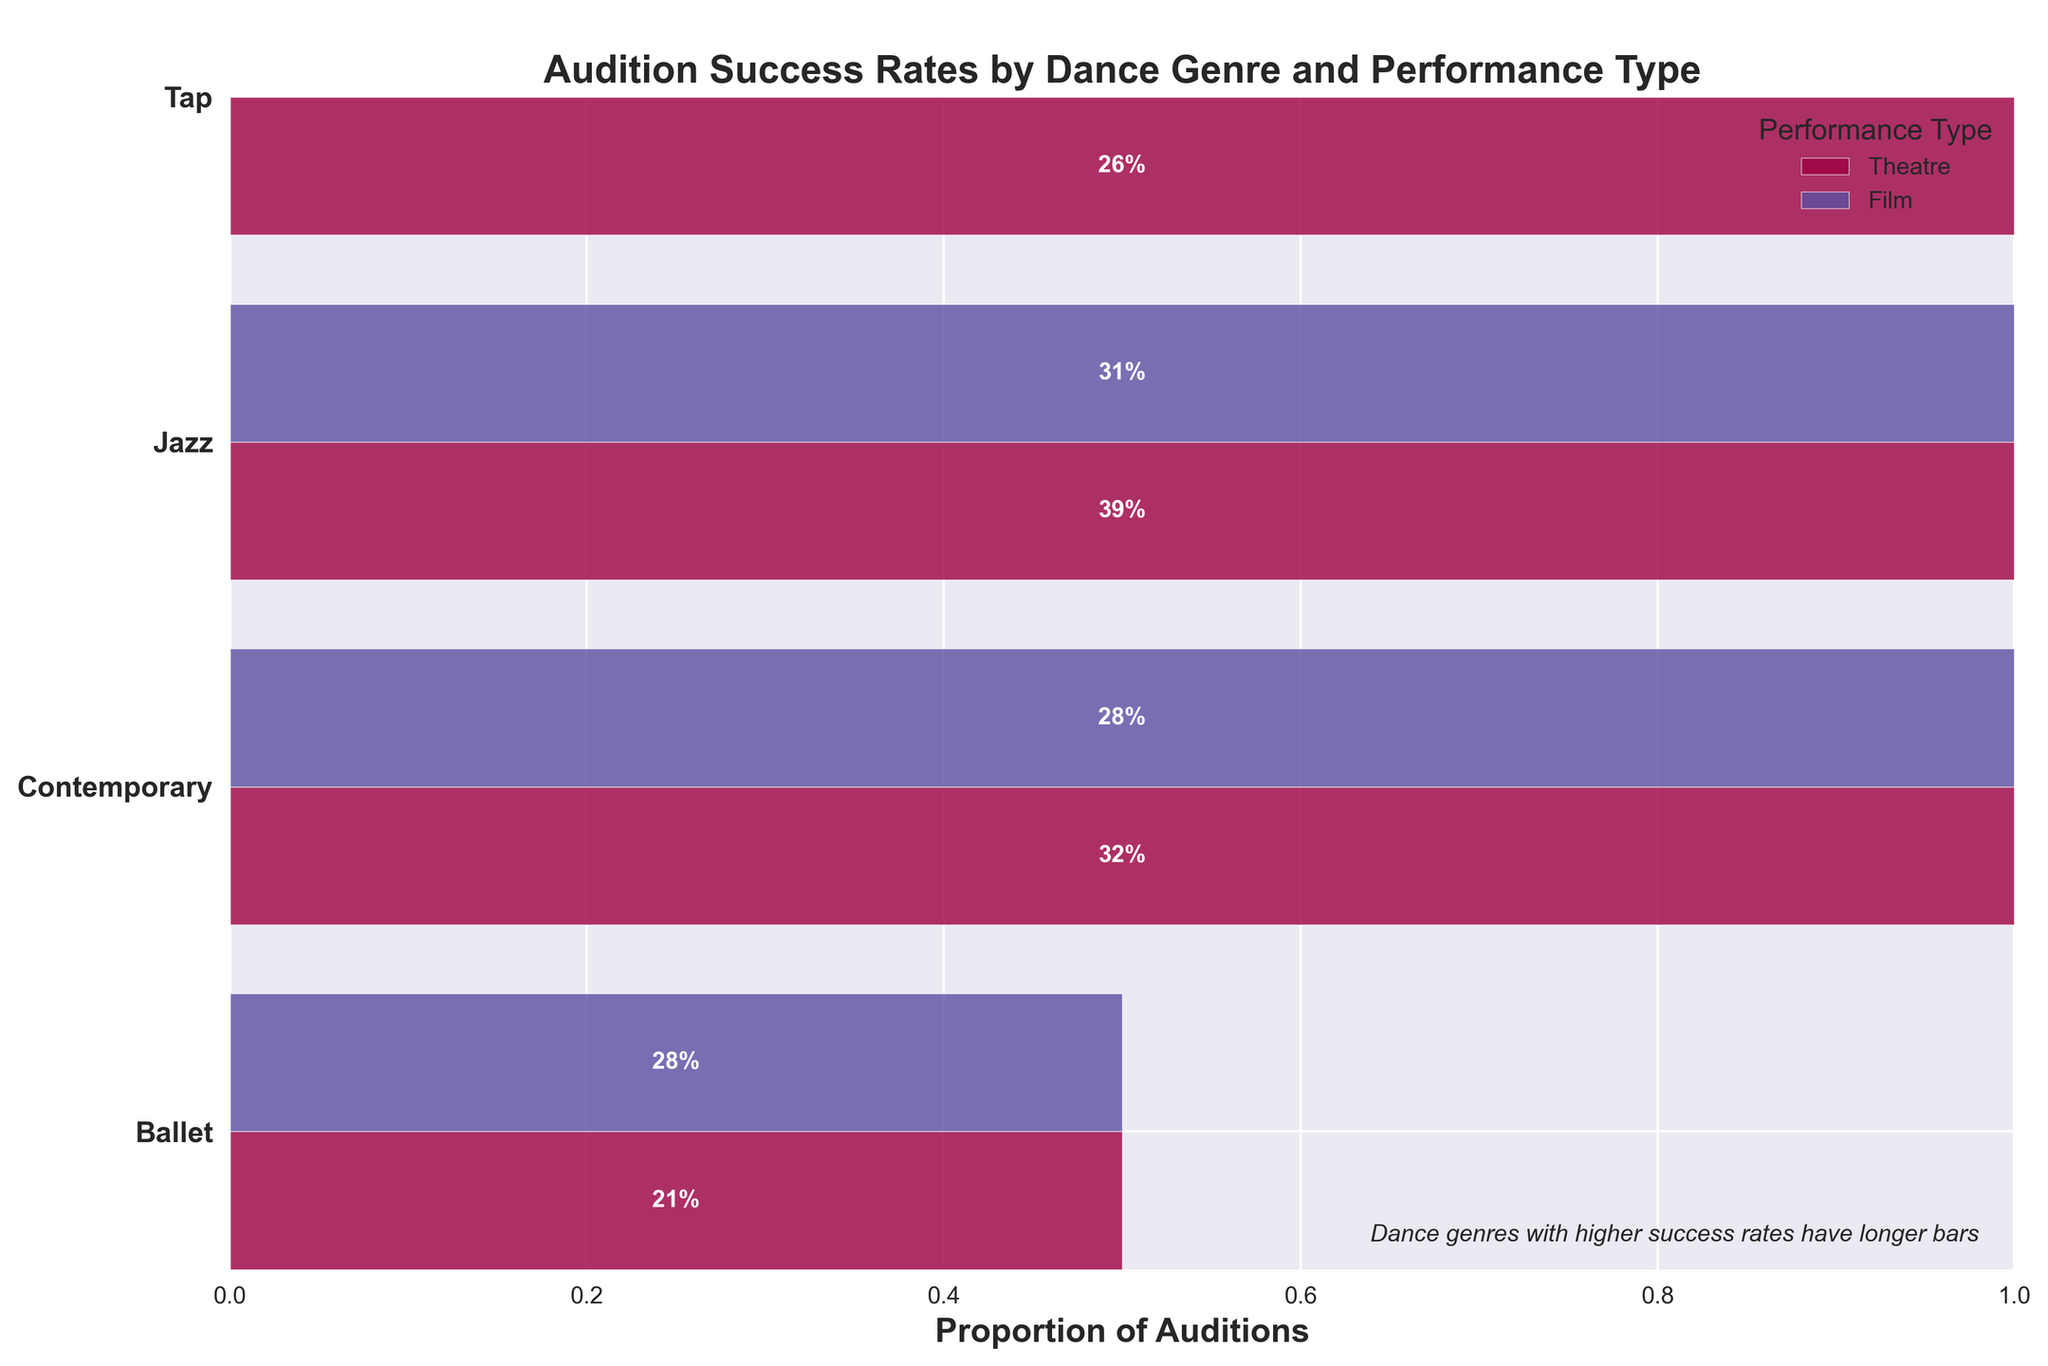How many dance genres are represented in the plot? The plot has 4 y-axis labels indicating the dance genres: Ballet, Contemporary, Jazz, and Tap.
Answer: 4 Which dance genre has the highest audition success rate for theatre performances? By looking at the length of the bars within each dance genre category for theatre performances, Jazz has the longest bar and a success rate of 39%.
Answer: Jazz What are the performance types depicted in the plot? The legend and labels show that there are two performance types: Theatre and Film.
Answer: Theatre and Film Among Ballet and Contemporary genres, which one has a higher overall audition success rate in film performances? Comparing the bar lengths for Ballet and Contemporary in film performances, Ballet has a success rate of 0.28 while Contemporary has a success rate of 0.28. Therefore, both genres have the same overall success rate.
Answer: Both are equal What is the success rate for Tap dance auditions in film performances? In the film section for Tap dance, the bar shows 35 successful auditions out of a total of 35 + 165 = 200. Thus, the success rate is 35/200 = 0.175 or 17.5%.
Answer: 17.5% How does the success rate for Ballet in theatre compare to Ballet in film performances? For Ballet in theatre, the success rate is 42 out of (42+158), which is 42/200 = 0.21 or 21%. For Ballet in film, the success rate is 28 out of (28+72), which is 28/100 = 0.28 or 28%. The success rate is higher for Ballet in film performances.
Answer: Film is higher Which dance genre has the highest variance in success rates between theatre and film performances? Calculate the difference in success rates for each genre between theatre and film. For Ballet, it is 0.07; for Contemporary, it is 0.1; for Jazz, it is 0.15; and for Tap, it is 0.145. Jazz has the highest variance.
Answer: Jazz What is the total audition count for Contemporary dance in theatre performances? Add the counts of attempts and successes for Contemporary in theatre performances: 65 (Success) + 135 (Failure) = 200.
Answer: 200 Is the audition success rate generally higher for theatre performances or film performances? By visually comparing the bars across all genres, theatre performances generally have higher success rates compared to film performances.
Answer: Theatre 